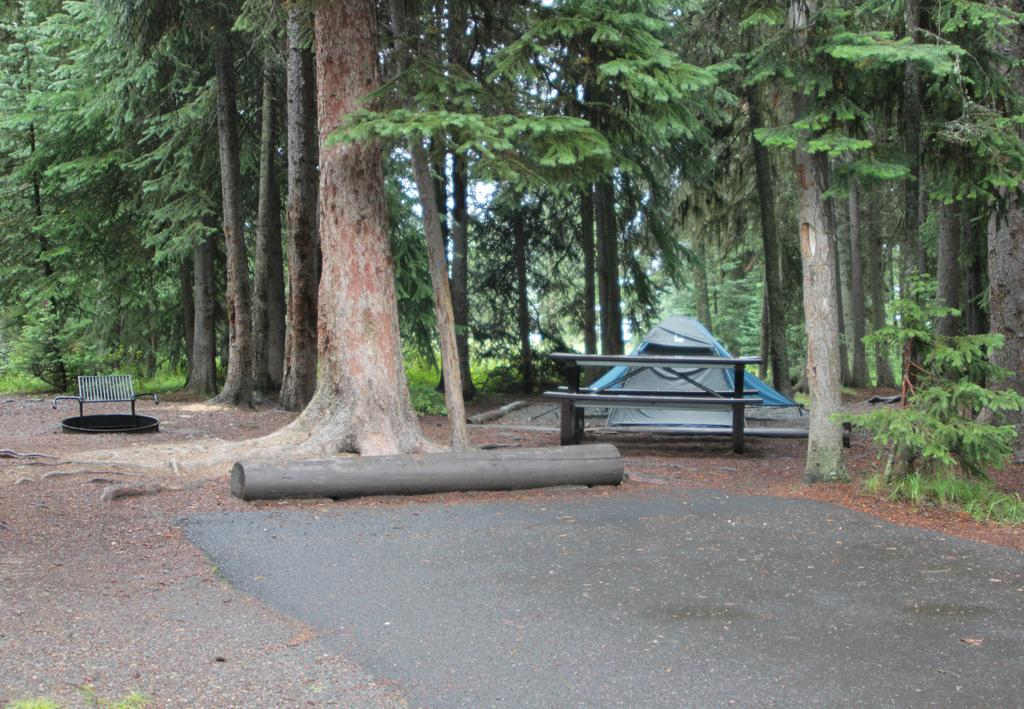What can be seen running through the image? There is a path in the image. What type of vegetation is present near the path? There are plants beside the path. What type of seating is available in the image? There is a bench in the image. Where is the bench located in relation to the trees? The bench is located among trees. What can be seen in the distance in the image? Trees are visible in the background of the image. What type of agreement is being signed on the bench in the image? There is no indication of an agreement or any signing activity in the image; it simply shows a bench among trees. 